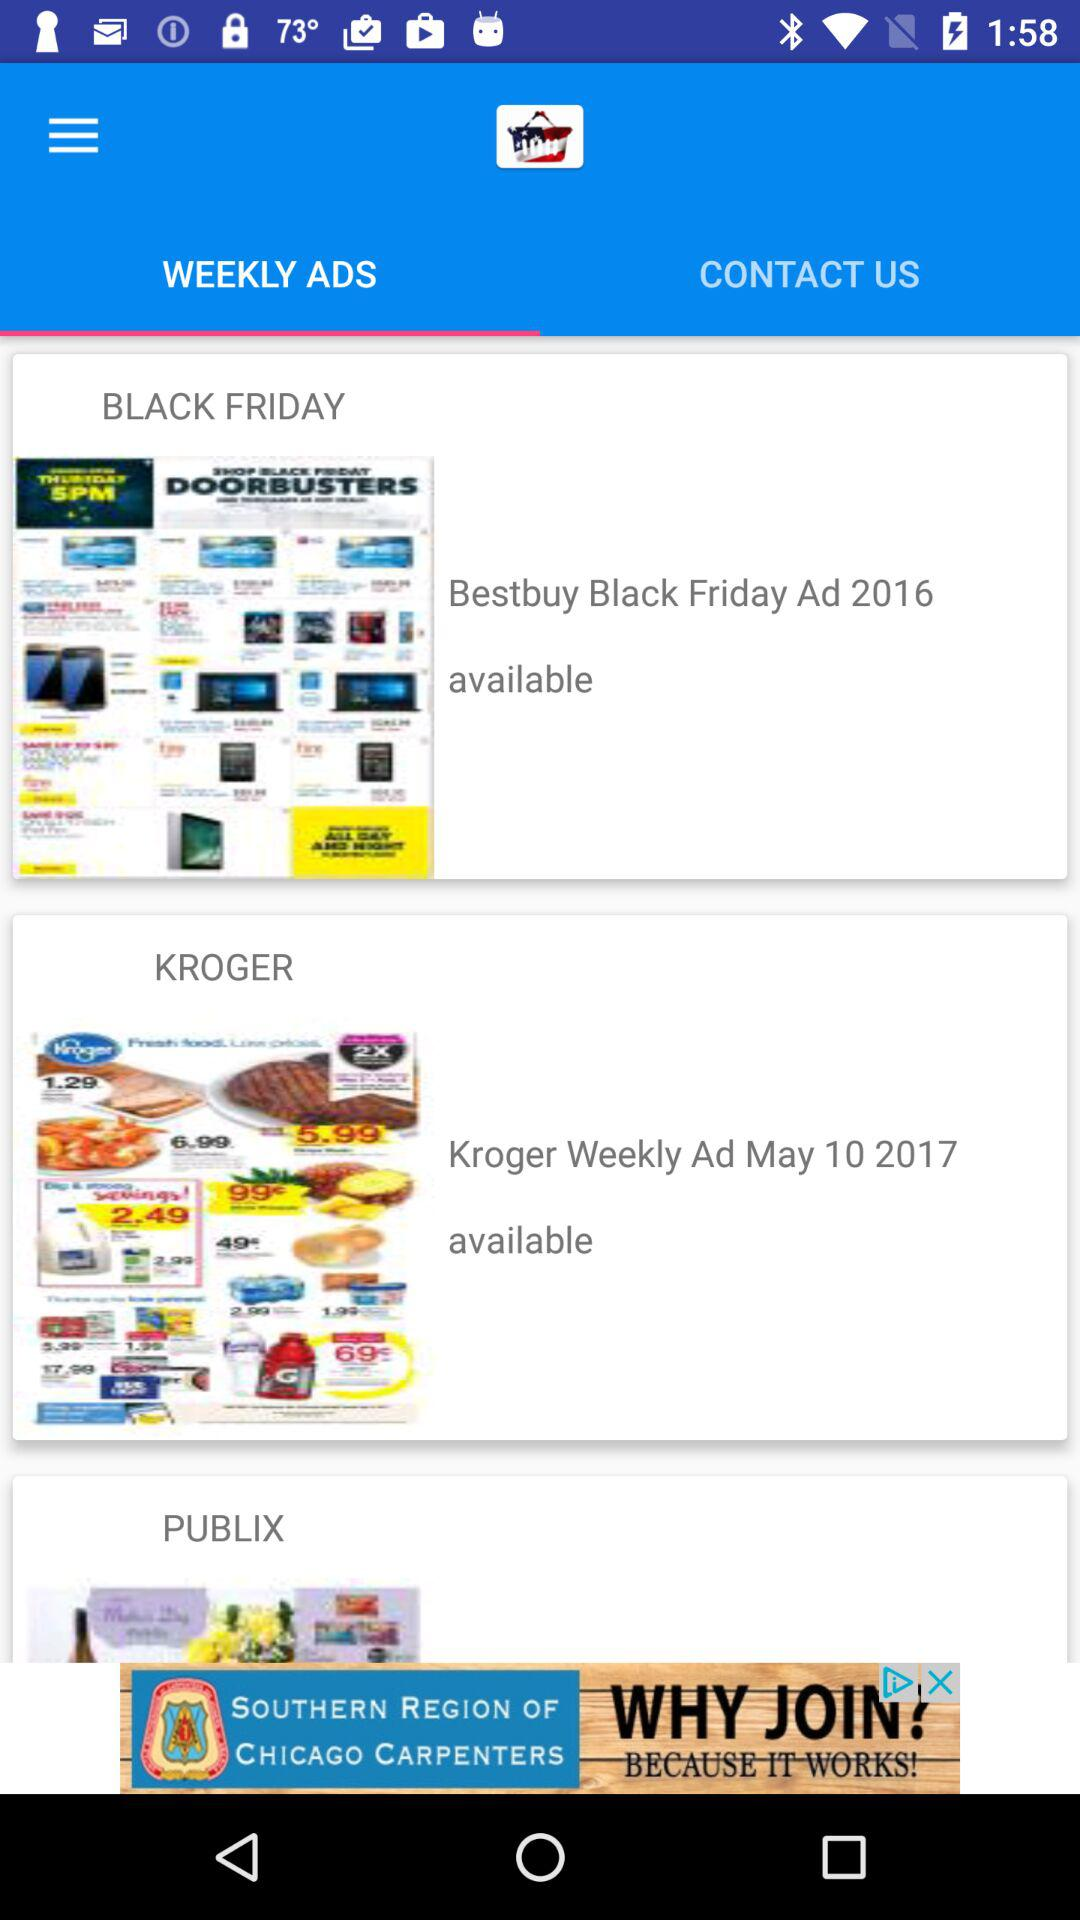How many ads have a date included?
Answer the question using a single word or phrase. 2 